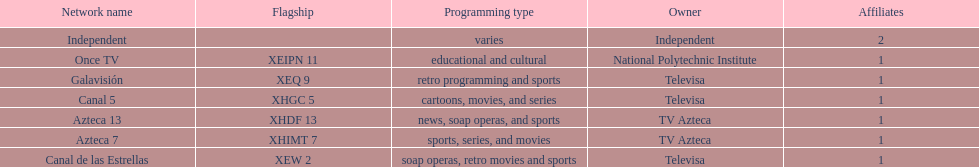How many networks are owned by televisa? 3. 